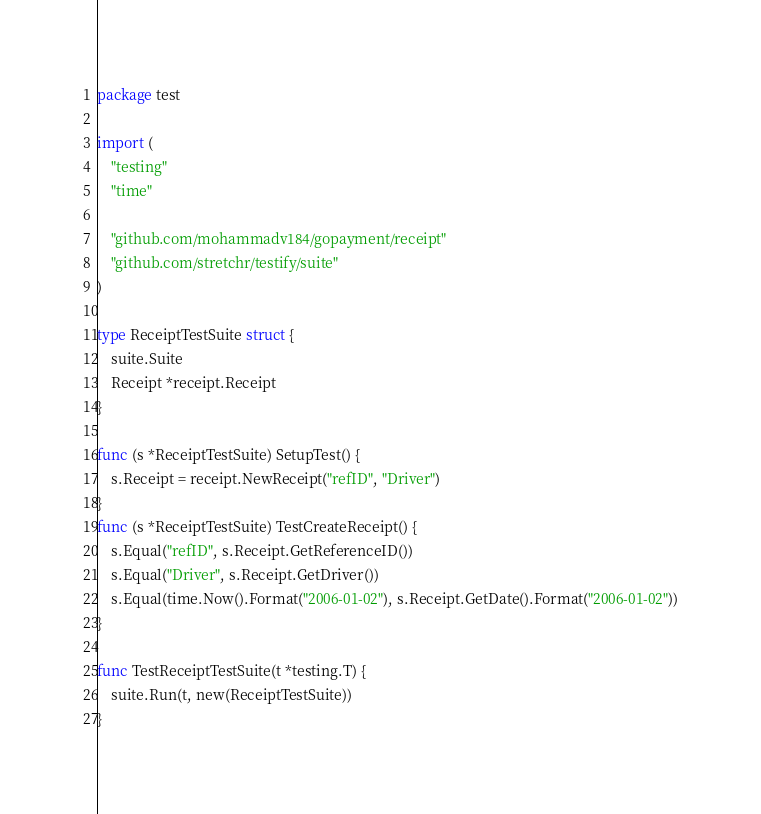Convert code to text. <code><loc_0><loc_0><loc_500><loc_500><_Go_>package test

import (
	"testing"
	"time"

	"github.com/mohammadv184/gopayment/receipt"
	"github.com/stretchr/testify/suite"
)

type ReceiptTestSuite struct {
	suite.Suite
	Receipt *receipt.Receipt
}

func (s *ReceiptTestSuite) SetupTest() {
	s.Receipt = receipt.NewReceipt("refID", "Driver")
}
func (s *ReceiptTestSuite) TestCreateReceipt() {
	s.Equal("refID", s.Receipt.GetReferenceID())
	s.Equal("Driver", s.Receipt.GetDriver())
	s.Equal(time.Now().Format("2006-01-02"), s.Receipt.GetDate().Format("2006-01-02"))
}

func TestReceiptTestSuite(t *testing.T) {
	suite.Run(t, new(ReceiptTestSuite))
}
</code> 